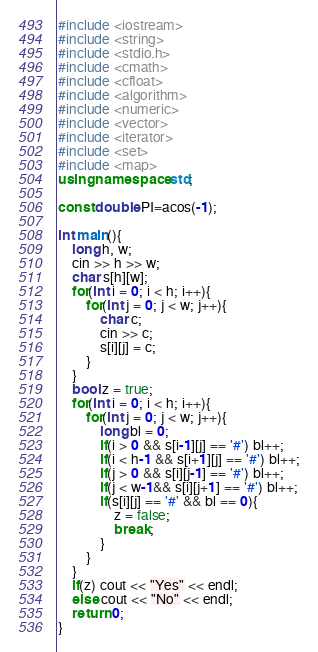Convert code to text. <code><loc_0><loc_0><loc_500><loc_500><_C++_>#include <iostream>
#include <string>
#include <stdio.h>
#include <cmath>
#include <cfloat>
#include <algorithm>
#include <numeric>
#include <vector>
#include <iterator>
#include <set>
#include <map>
using namespace std;

const double PI=acos(-1);

int main(){
    long h, w;
    cin >> h >> w;
    char s[h][w];
    for(int i = 0; i < h; i++){
        for(int j = 0; j < w; j++){
            char c;
            cin >> c;
            s[i][j] = c;
        }
    }
    bool z = true;
    for(int i = 0; i < h; i++){
        for(int j = 0; j < w; j++){
            long bl = 0;
            if(i > 0 && s[i-1][j] == '#') bl++;
            if(i < h-1 && s[i+1][j] == '#') bl++;
            if(j > 0 && s[i][j-1] == '#') bl++;
            if(j < w-1&& s[i][j+1] == '#') bl++;
            if(s[i][j] == '#' && bl == 0){
                z = false;
                break;
            }
        }
    }
    if(z) cout << "Yes" << endl;
    else cout << "No" << endl;
    return 0;
}</code> 